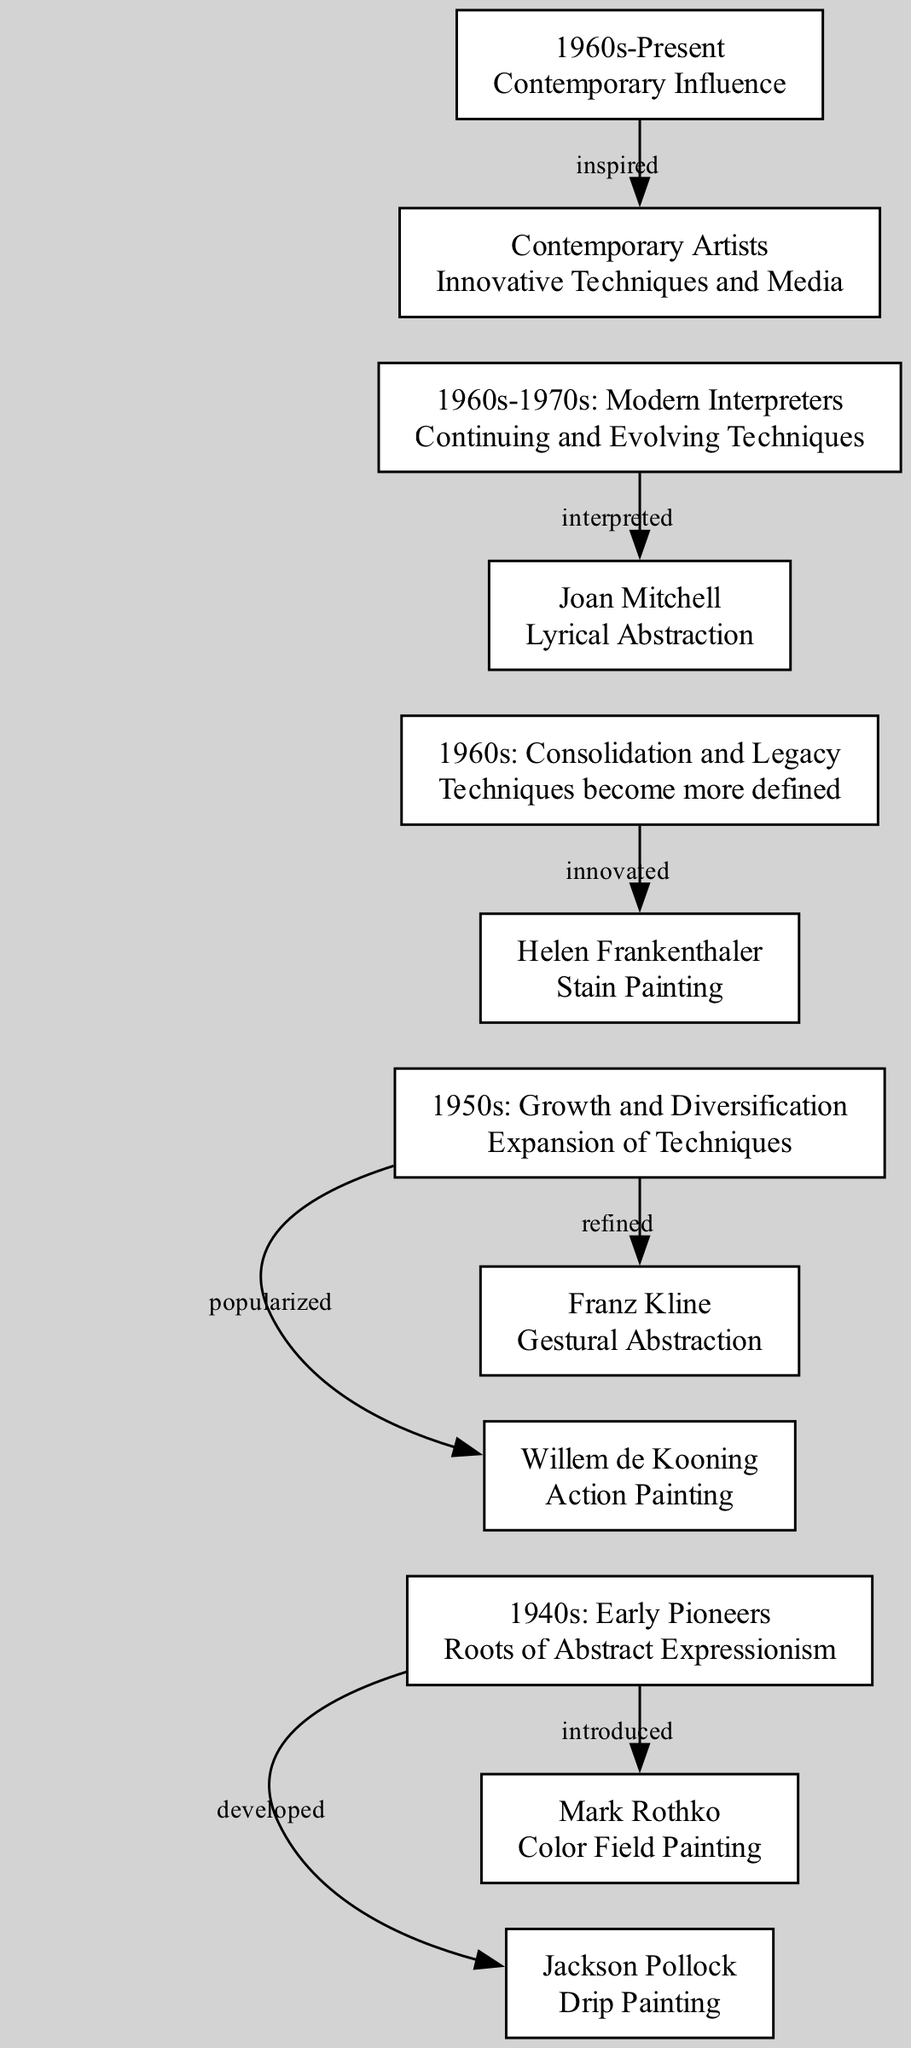What decade marks the roots of Abstract Expressionism? According to the diagram, the node labeled "1940s: Early Pioneers" indicates that the origins of Abstract Expressionism began in the 1940s.
Answer: 1940s Who is associated with Drip Painting? The diagram shows the connection from the "1940s: Early Pioneers" node to the "Jackson Pollock" node, which explicitly states that he is known for developing the technique of Drip Painting.
Answer: Jackson Pollock How many artists' techniques are highlighted in the 1950s? The 1950s node "Growth and Diversification" connects to two artist nodes: "Willem de Kooning" and "Franz Kline," which means there are two mentioned artists' techniques from that decade.
Answer: 2 What technique did Helen Frankenthaler innovate in the 1960s? The diagram indicates that Helen Frankenthaler is linked under the "1960s: Consolidation and Legacy" node, and her technique is noted as "Stain Painting," directly showing the innovative technique attributed to her during this time.
Answer: Stain Painting Which artist is associated with Lyrical Abstraction? Following the connections in the diagram, "Joan Mitchell" directly links from the "1960s-1970s: Modern Interpreters" node to the "interpreted" statement, implying she is known for the Lyrical Abstraction technique.
Answer: Joan Mitchell What describes the evolution of techniques in the 1960s and 1970s? The diagram specifies the node labeled "1960s-1970s: Modern Interpreters," which states that the techniques continued and evolved during this time, highlighting a progression in artistic expression.
Answer: Continuing and Evolving Techniques What relationship exists between the 1960s and contemporary artists? According to the diagram, there is a direct link from the "1960s-Present" node to the "Contemporary Artists" node, denoted as "inspired," indicating that contemporary artists are influenced by artistic developments from the earlier time period.
Answer: Inspired How did the techniques change from the 1940s to the 1960s? The diagram shows a progression from the "1940s: Early Pioneers" through the "1950s: Growth and Diversification" to the "1960s: Consolidation and Legacy," illustrating an expansion and refinement in techniques across these decades.
Answer: Expansion and Refinement What color field painting technique was introduced by a pioneer? The diagram connects "Mark Rothko" from the "1940s: Early Pioneers" node as the artist who introduced "Color Field Painting," a significant technique in Abstract Expressionism.
Answer: Color Field Painting 